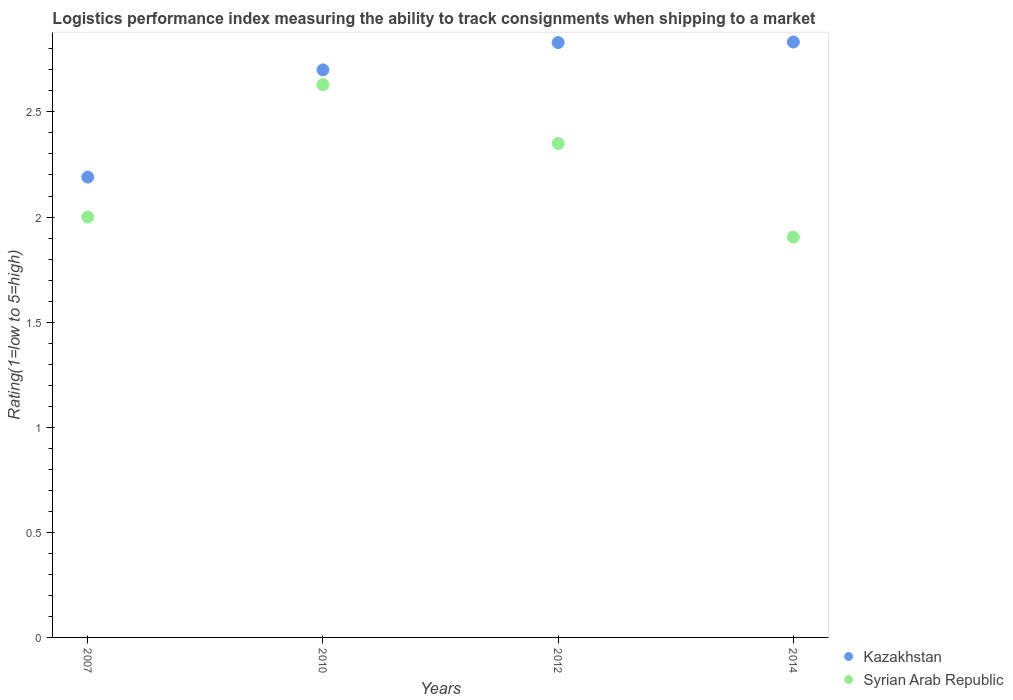How many different coloured dotlines are there?
Your answer should be compact. 2. What is the Logistic performance index in Kazakhstan in 2007?
Ensure brevity in your answer.  2.19. Across all years, what is the maximum Logistic performance index in Syrian Arab Republic?
Your response must be concise. 2.63. Across all years, what is the minimum Logistic performance index in Syrian Arab Republic?
Your response must be concise. 1.9. What is the total Logistic performance index in Syrian Arab Republic in the graph?
Your answer should be compact. 8.88. What is the difference between the Logistic performance index in Kazakhstan in 2007 and that in 2014?
Your answer should be compact. -0.64. What is the difference between the Logistic performance index in Syrian Arab Republic in 2007 and the Logistic performance index in Kazakhstan in 2010?
Offer a terse response. -0.7. What is the average Logistic performance index in Syrian Arab Republic per year?
Your answer should be compact. 2.22. In the year 2014, what is the difference between the Logistic performance index in Kazakhstan and Logistic performance index in Syrian Arab Republic?
Ensure brevity in your answer.  0.93. In how many years, is the Logistic performance index in Syrian Arab Republic greater than 1.9?
Provide a short and direct response. 4. What is the ratio of the Logistic performance index in Kazakhstan in 2010 to that in 2012?
Offer a terse response. 0.95. What is the difference between the highest and the second highest Logistic performance index in Kazakhstan?
Keep it short and to the point. 0. What is the difference between the highest and the lowest Logistic performance index in Kazakhstan?
Keep it short and to the point. 0.64. Does the Logistic performance index in Syrian Arab Republic monotonically increase over the years?
Make the answer very short. No. Is the Logistic performance index in Syrian Arab Republic strictly less than the Logistic performance index in Kazakhstan over the years?
Provide a short and direct response. Yes. Are the values on the major ticks of Y-axis written in scientific E-notation?
Offer a very short reply. No. Does the graph contain any zero values?
Provide a short and direct response. No. Where does the legend appear in the graph?
Provide a succinct answer. Bottom right. How many legend labels are there?
Make the answer very short. 2. What is the title of the graph?
Your response must be concise. Logistics performance index measuring the ability to track consignments when shipping to a market. What is the label or title of the Y-axis?
Ensure brevity in your answer.  Rating(1=low to 5=high). What is the Rating(1=low to 5=high) of Kazakhstan in 2007?
Your answer should be compact. 2.19. What is the Rating(1=low to 5=high) of Syrian Arab Republic in 2007?
Your response must be concise. 2. What is the Rating(1=low to 5=high) of Kazakhstan in 2010?
Your answer should be very brief. 2.7. What is the Rating(1=low to 5=high) of Syrian Arab Republic in 2010?
Provide a succinct answer. 2.63. What is the Rating(1=low to 5=high) of Kazakhstan in 2012?
Ensure brevity in your answer.  2.83. What is the Rating(1=low to 5=high) in Syrian Arab Republic in 2012?
Provide a short and direct response. 2.35. What is the Rating(1=low to 5=high) of Kazakhstan in 2014?
Give a very brief answer. 2.83. What is the Rating(1=low to 5=high) of Syrian Arab Republic in 2014?
Keep it short and to the point. 1.9. Across all years, what is the maximum Rating(1=low to 5=high) in Kazakhstan?
Give a very brief answer. 2.83. Across all years, what is the maximum Rating(1=low to 5=high) in Syrian Arab Republic?
Ensure brevity in your answer.  2.63. Across all years, what is the minimum Rating(1=low to 5=high) in Kazakhstan?
Give a very brief answer. 2.19. Across all years, what is the minimum Rating(1=low to 5=high) in Syrian Arab Republic?
Make the answer very short. 1.9. What is the total Rating(1=low to 5=high) in Kazakhstan in the graph?
Your response must be concise. 10.55. What is the total Rating(1=low to 5=high) in Syrian Arab Republic in the graph?
Your response must be concise. 8.88. What is the difference between the Rating(1=low to 5=high) in Kazakhstan in 2007 and that in 2010?
Keep it short and to the point. -0.51. What is the difference between the Rating(1=low to 5=high) of Syrian Arab Republic in 2007 and that in 2010?
Your answer should be very brief. -0.63. What is the difference between the Rating(1=low to 5=high) of Kazakhstan in 2007 and that in 2012?
Provide a short and direct response. -0.64. What is the difference between the Rating(1=low to 5=high) in Syrian Arab Republic in 2007 and that in 2012?
Offer a very short reply. -0.35. What is the difference between the Rating(1=low to 5=high) of Kazakhstan in 2007 and that in 2014?
Give a very brief answer. -0.64. What is the difference between the Rating(1=low to 5=high) of Syrian Arab Republic in 2007 and that in 2014?
Your answer should be very brief. 0.1. What is the difference between the Rating(1=low to 5=high) in Kazakhstan in 2010 and that in 2012?
Your answer should be compact. -0.13. What is the difference between the Rating(1=low to 5=high) of Syrian Arab Republic in 2010 and that in 2012?
Ensure brevity in your answer.  0.28. What is the difference between the Rating(1=low to 5=high) in Kazakhstan in 2010 and that in 2014?
Your response must be concise. -0.13. What is the difference between the Rating(1=low to 5=high) in Syrian Arab Republic in 2010 and that in 2014?
Provide a short and direct response. 0.73. What is the difference between the Rating(1=low to 5=high) of Kazakhstan in 2012 and that in 2014?
Offer a terse response. -0. What is the difference between the Rating(1=low to 5=high) of Syrian Arab Republic in 2012 and that in 2014?
Your answer should be very brief. 0.45. What is the difference between the Rating(1=low to 5=high) of Kazakhstan in 2007 and the Rating(1=low to 5=high) of Syrian Arab Republic in 2010?
Your answer should be compact. -0.44. What is the difference between the Rating(1=low to 5=high) in Kazakhstan in 2007 and the Rating(1=low to 5=high) in Syrian Arab Republic in 2012?
Give a very brief answer. -0.16. What is the difference between the Rating(1=low to 5=high) of Kazakhstan in 2007 and the Rating(1=low to 5=high) of Syrian Arab Republic in 2014?
Your answer should be very brief. 0.29. What is the difference between the Rating(1=low to 5=high) in Kazakhstan in 2010 and the Rating(1=low to 5=high) in Syrian Arab Republic in 2014?
Your answer should be compact. 0.8. What is the difference between the Rating(1=low to 5=high) of Kazakhstan in 2012 and the Rating(1=low to 5=high) of Syrian Arab Republic in 2014?
Keep it short and to the point. 0.93. What is the average Rating(1=low to 5=high) in Kazakhstan per year?
Keep it short and to the point. 2.64. What is the average Rating(1=low to 5=high) of Syrian Arab Republic per year?
Give a very brief answer. 2.22. In the year 2007, what is the difference between the Rating(1=low to 5=high) of Kazakhstan and Rating(1=low to 5=high) of Syrian Arab Republic?
Your answer should be very brief. 0.19. In the year 2010, what is the difference between the Rating(1=low to 5=high) of Kazakhstan and Rating(1=low to 5=high) of Syrian Arab Republic?
Your answer should be very brief. 0.07. In the year 2012, what is the difference between the Rating(1=low to 5=high) of Kazakhstan and Rating(1=low to 5=high) of Syrian Arab Republic?
Your response must be concise. 0.48. In the year 2014, what is the difference between the Rating(1=low to 5=high) of Kazakhstan and Rating(1=low to 5=high) of Syrian Arab Republic?
Provide a short and direct response. 0.93. What is the ratio of the Rating(1=low to 5=high) of Kazakhstan in 2007 to that in 2010?
Offer a terse response. 0.81. What is the ratio of the Rating(1=low to 5=high) in Syrian Arab Republic in 2007 to that in 2010?
Your answer should be very brief. 0.76. What is the ratio of the Rating(1=low to 5=high) in Kazakhstan in 2007 to that in 2012?
Keep it short and to the point. 0.77. What is the ratio of the Rating(1=low to 5=high) in Syrian Arab Republic in 2007 to that in 2012?
Keep it short and to the point. 0.85. What is the ratio of the Rating(1=low to 5=high) in Kazakhstan in 2007 to that in 2014?
Provide a succinct answer. 0.77. What is the ratio of the Rating(1=low to 5=high) of Syrian Arab Republic in 2007 to that in 2014?
Your answer should be compact. 1.05. What is the ratio of the Rating(1=low to 5=high) of Kazakhstan in 2010 to that in 2012?
Offer a terse response. 0.95. What is the ratio of the Rating(1=low to 5=high) in Syrian Arab Republic in 2010 to that in 2012?
Provide a succinct answer. 1.12. What is the ratio of the Rating(1=low to 5=high) of Kazakhstan in 2010 to that in 2014?
Ensure brevity in your answer.  0.95. What is the ratio of the Rating(1=low to 5=high) in Syrian Arab Republic in 2010 to that in 2014?
Your answer should be compact. 1.38. What is the ratio of the Rating(1=low to 5=high) of Kazakhstan in 2012 to that in 2014?
Keep it short and to the point. 1. What is the ratio of the Rating(1=low to 5=high) of Syrian Arab Republic in 2012 to that in 2014?
Your response must be concise. 1.23. What is the difference between the highest and the second highest Rating(1=low to 5=high) in Kazakhstan?
Provide a short and direct response. 0. What is the difference between the highest and the second highest Rating(1=low to 5=high) in Syrian Arab Republic?
Keep it short and to the point. 0.28. What is the difference between the highest and the lowest Rating(1=low to 5=high) in Kazakhstan?
Make the answer very short. 0.64. What is the difference between the highest and the lowest Rating(1=low to 5=high) in Syrian Arab Republic?
Keep it short and to the point. 0.73. 